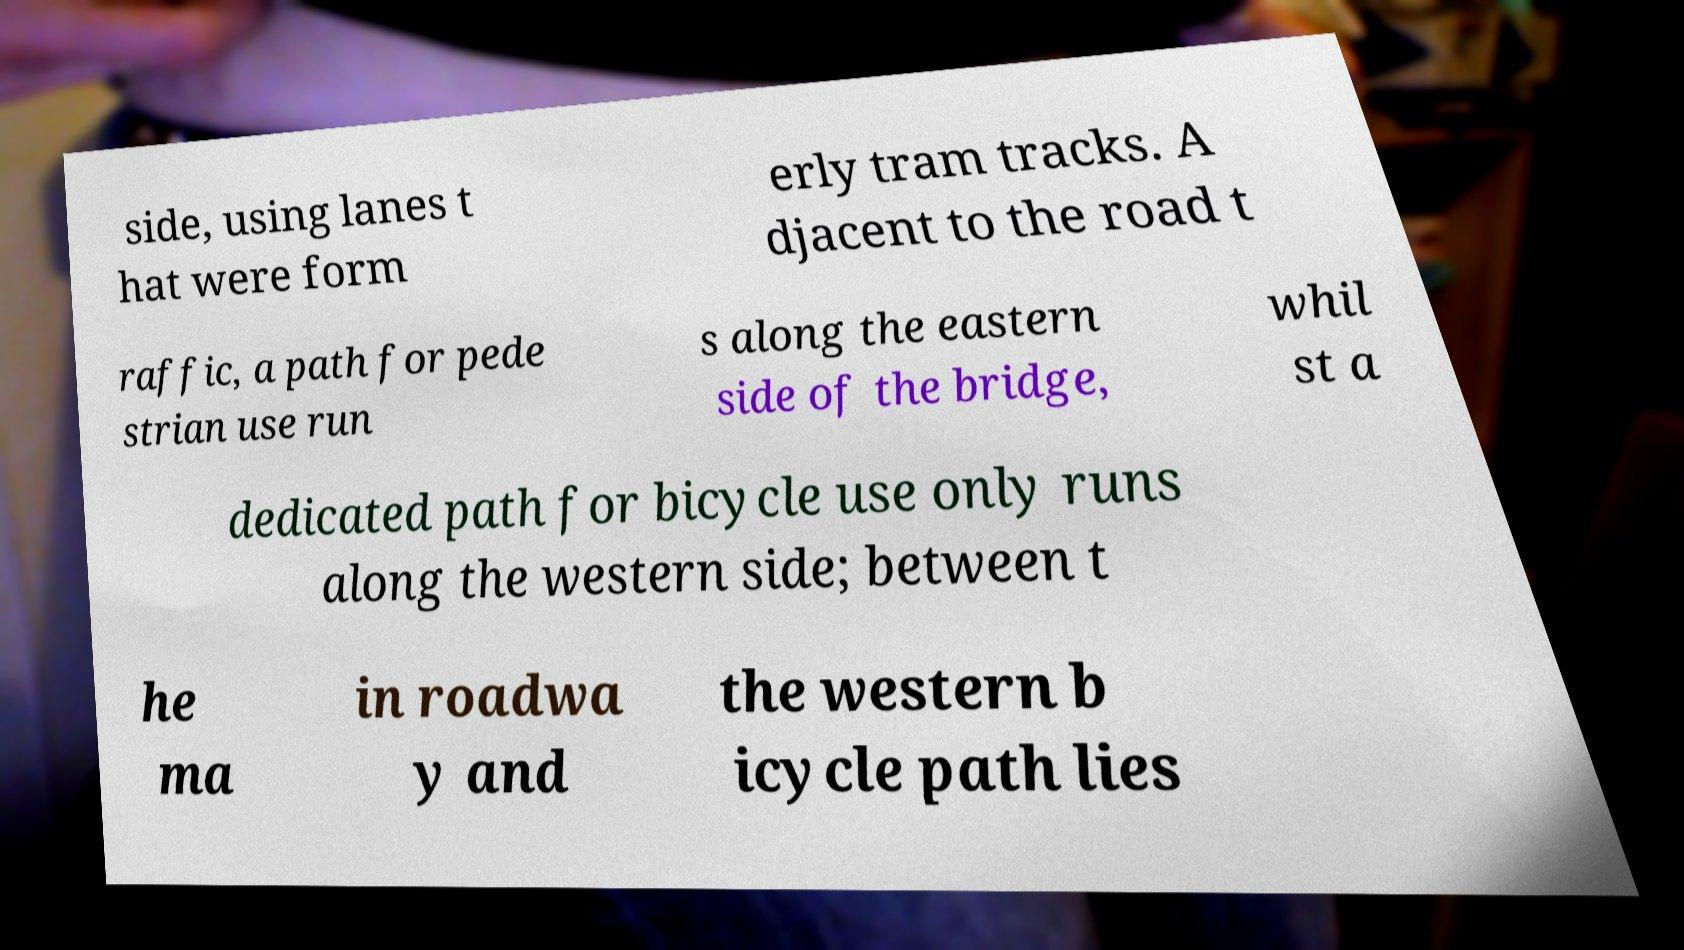Can you accurately transcribe the text from the provided image for me? side, using lanes t hat were form erly tram tracks. A djacent to the road t raffic, a path for pede strian use run s along the eastern side of the bridge, whil st a dedicated path for bicycle use only runs along the western side; between t he ma in roadwa y and the western b icycle path lies 